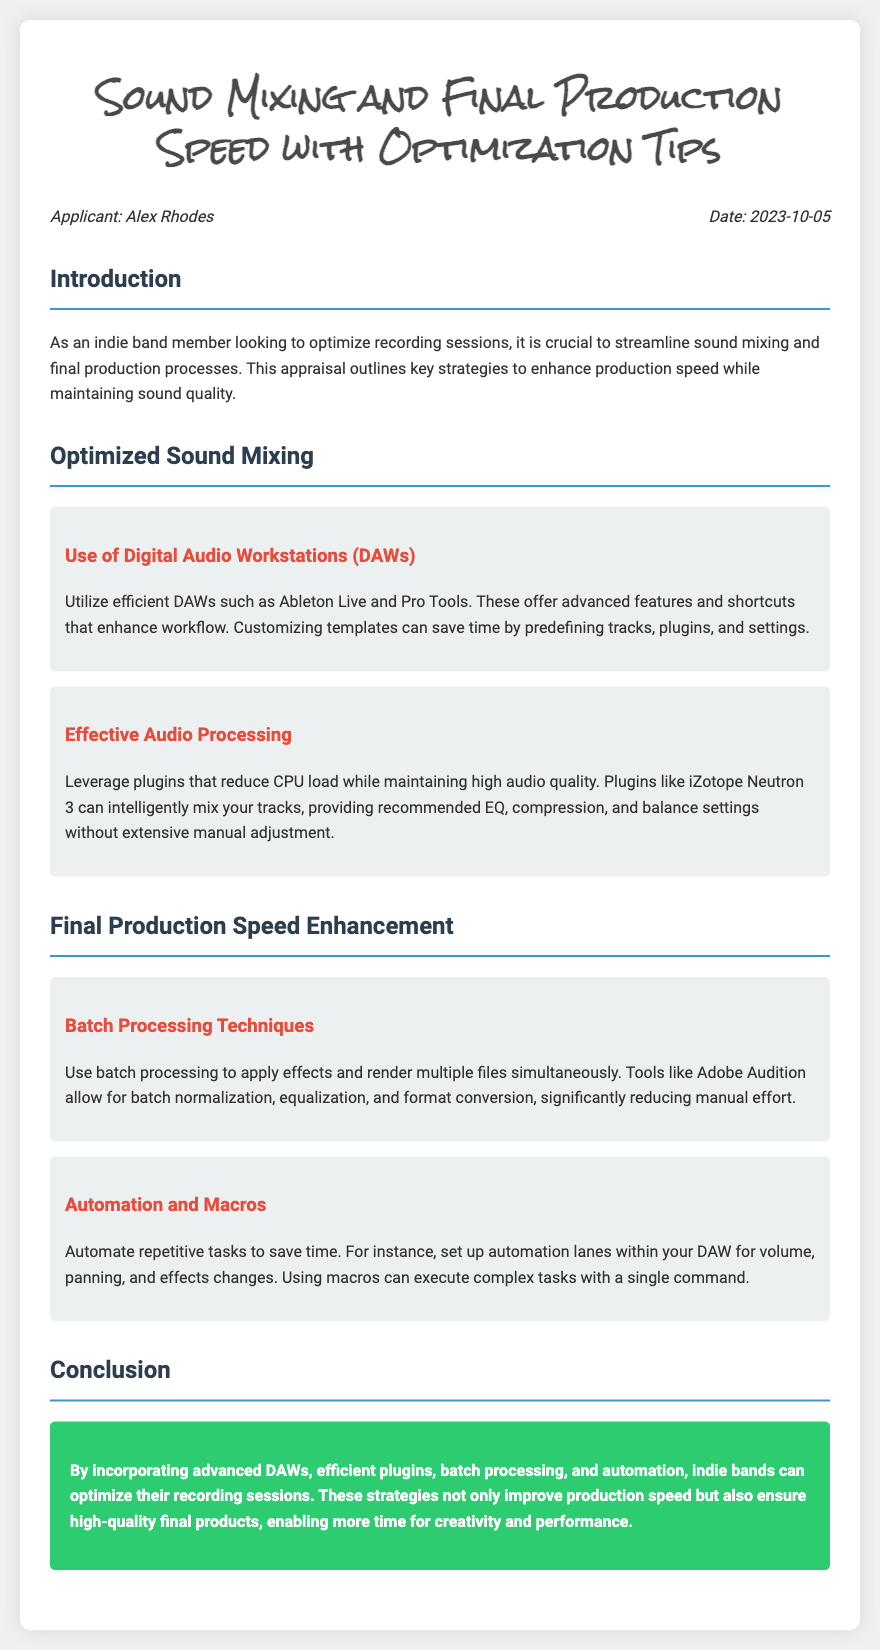What is the applicant's name? The applicant's name is listed at the top of the document under the meta-info section.
Answer: Alex Rhodes What date was the appraisal completed? The date is specified in the meta-info section of the document.
Answer: 2023-10-05 What DAWs are recommended for optimized sound mixing? The document mentions specific software tools in the optimized sound mixing section.
Answer: Ableton Live and Pro Tools What effect does iZotope Neutron 3 have on audio quality? The document describes how this plugin integrates with the mixing process.
Answer: Maintains high audio quality What technique can significantly reduce manual effort in production speed? The document suggests specific methods within the final production speed enhancement section.
Answer: Batch processing What does automation help to save in terms of production processes? The document describes the advantages of setting automation lanes in the DAW.
Answer: Time What is the focus of the conclusion in the document? The conclusion summarizes the key strategies outlined throughout the document.
Answer: Optimizing recording sessions Which type of processing allows for the rendering of multiple files simultaneously? This process is detailed in the final production speed enhancement section.
Answer: Batch processing What is the overall goal of the appraisal? The introduction section outlines the purpose of the document.
Answer: Optimize recording sessions 